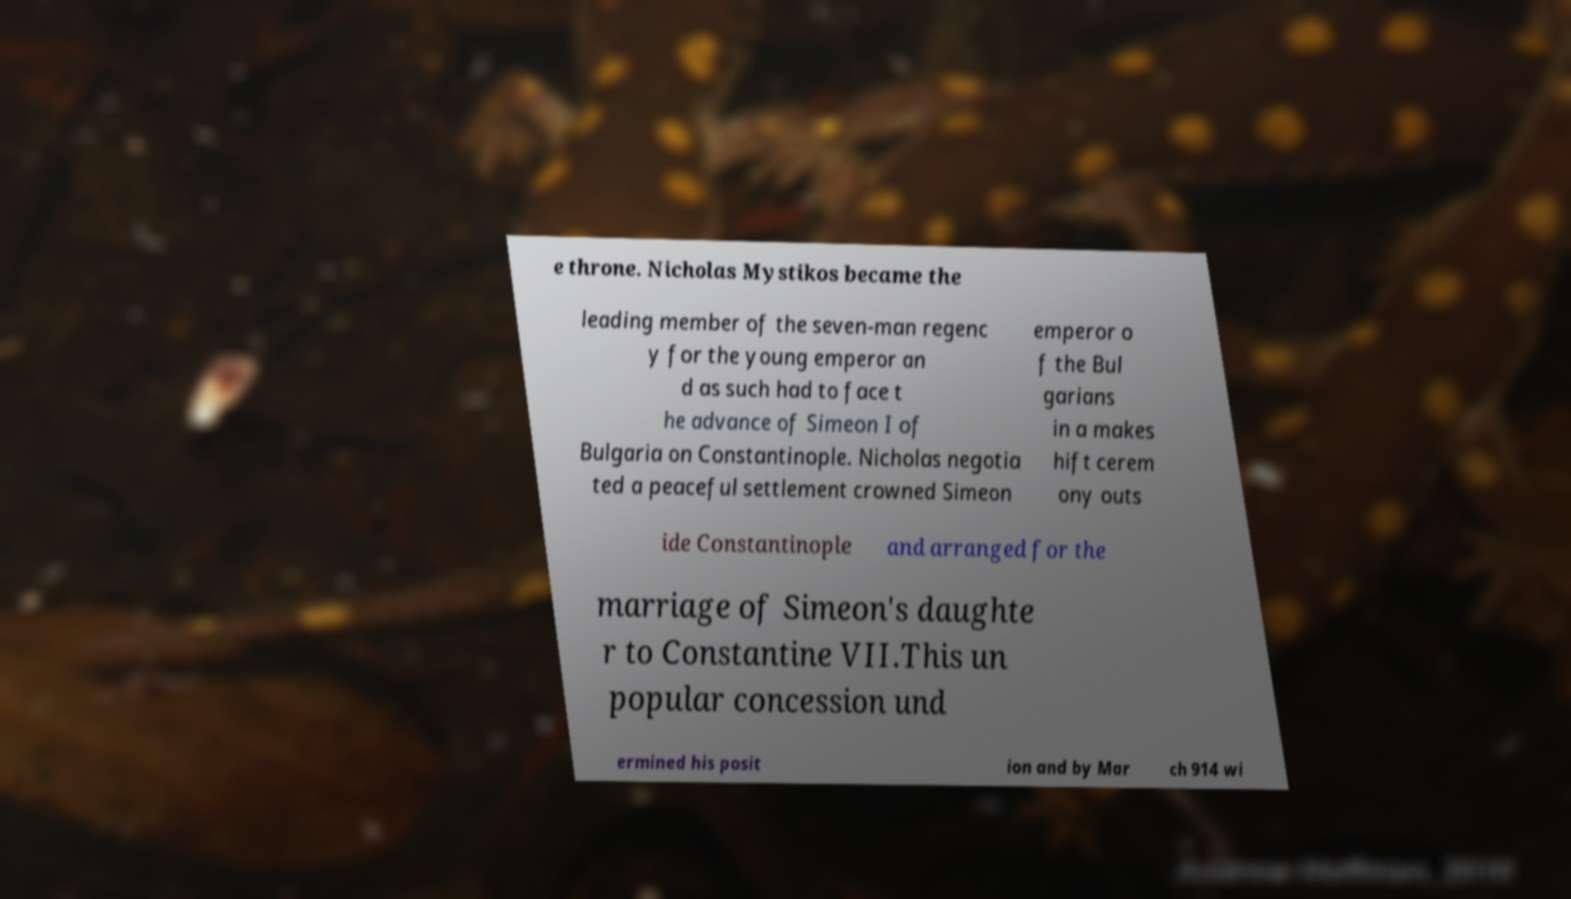Please identify and transcribe the text found in this image. e throne. Nicholas Mystikos became the leading member of the seven-man regenc y for the young emperor an d as such had to face t he advance of Simeon I of Bulgaria on Constantinople. Nicholas negotia ted a peaceful settlement crowned Simeon emperor o f the Bul garians in a makes hift cerem ony outs ide Constantinople and arranged for the marriage of Simeon's daughte r to Constantine VII.This un popular concession und ermined his posit ion and by Mar ch 914 wi 